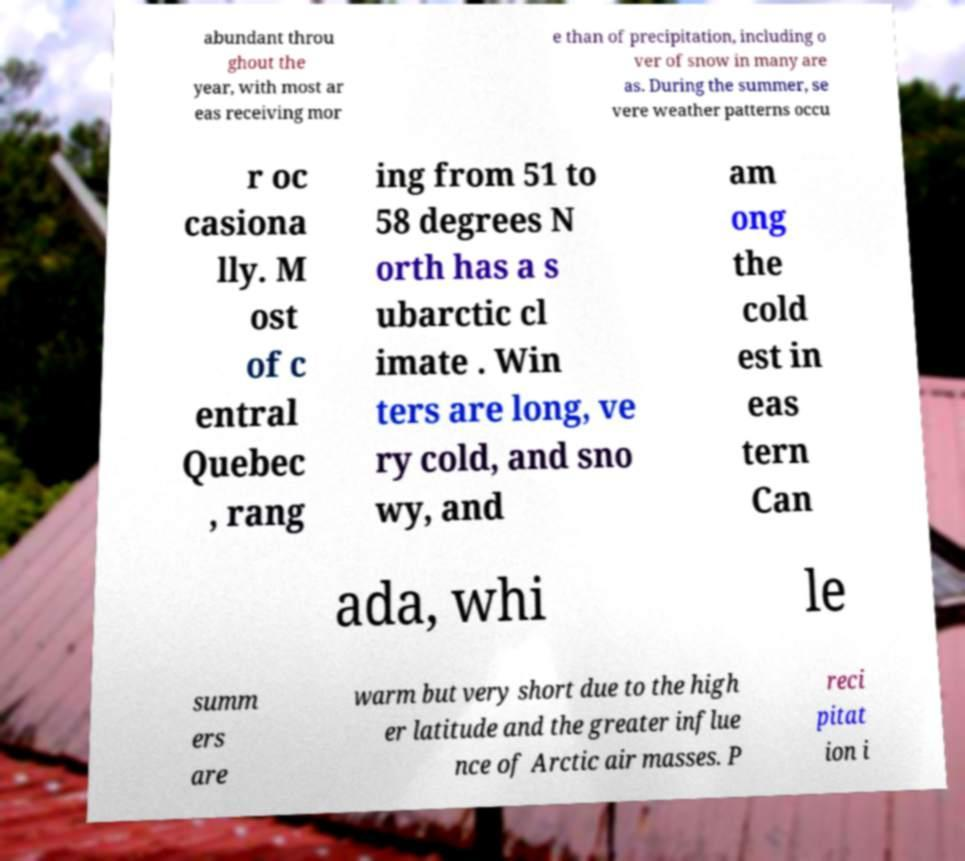Could you extract and type out the text from this image? abundant throu ghout the year, with most ar eas receiving mor e than of precipitation, including o ver of snow in many are as. During the summer, se vere weather patterns occu r oc casiona lly. M ost of c entral Quebec , rang ing from 51 to 58 degrees N orth has a s ubarctic cl imate . Win ters are long, ve ry cold, and sno wy, and am ong the cold est in eas tern Can ada, whi le summ ers are warm but very short due to the high er latitude and the greater influe nce of Arctic air masses. P reci pitat ion i 